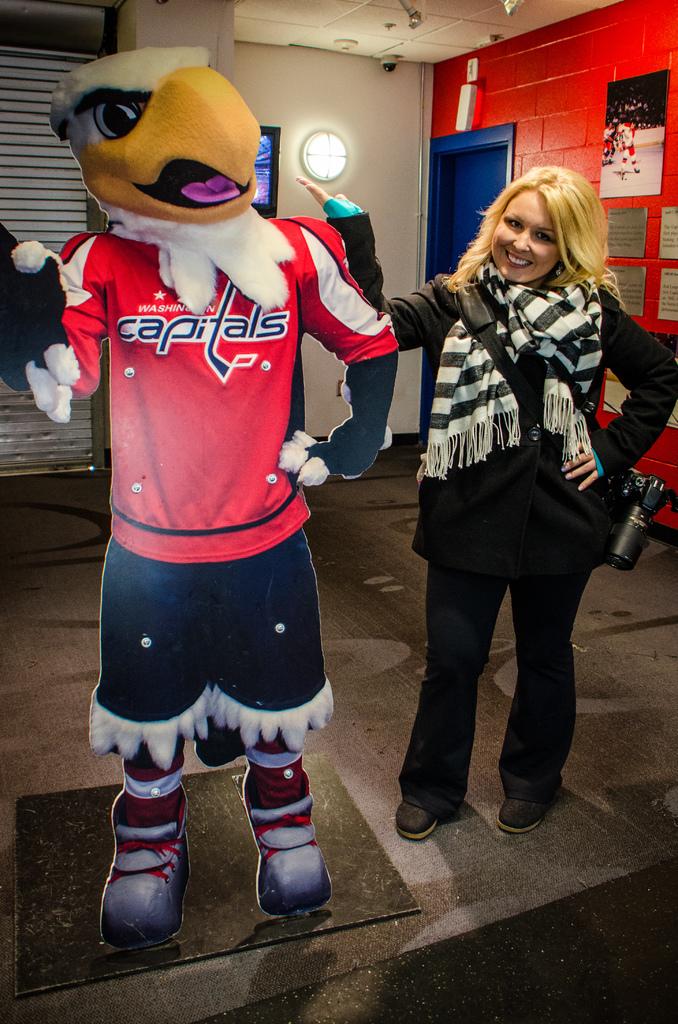What state or city is the team from?
Provide a succinct answer. Washington. 